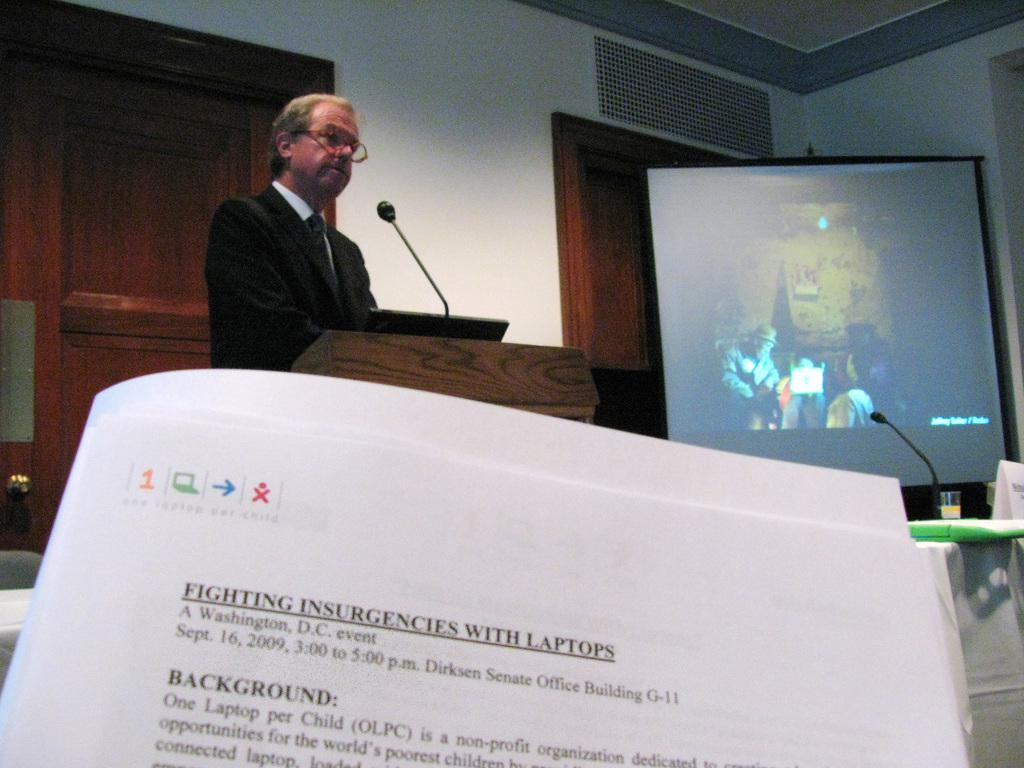<image>
Write a terse but informative summary of the picture. Somebody is presiding over a lecture, you can see a syllabus with the title Fighting insurgencies with laptops 